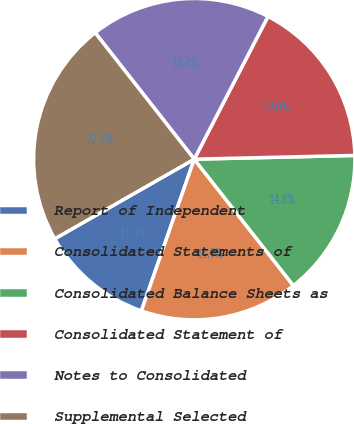Convert chart. <chart><loc_0><loc_0><loc_500><loc_500><pie_chart><fcel>Report of Independent<fcel>Consolidated Statements of<fcel>Consolidated Balance Sheets as<fcel>Consolidated Statement of<fcel>Notes to Consolidated<fcel>Supplemental Selected<nl><fcel>11.41%<fcel>15.92%<fcel>14.79%<fcel>17.04%<fcel>18.17%<fcel>22.67%<nl></chart> 